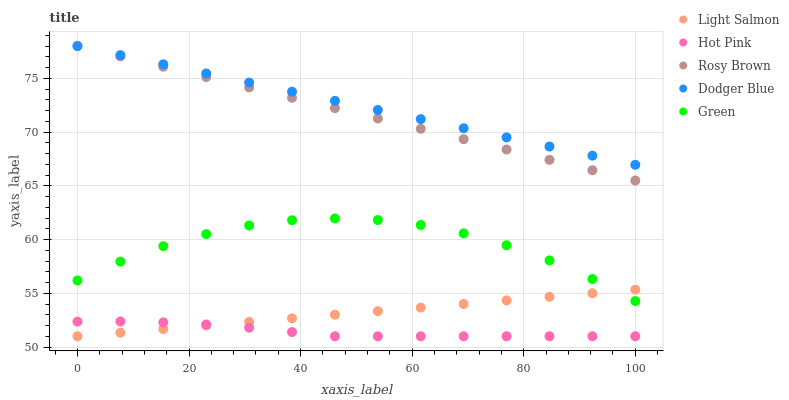Does Hot Pink have the minimum area under the curve?
Answer yes or no. Yes. Does Dodger Blue have the maximum area under the curve?
Answer yes or no. Yes. Does Light Salmon have the minimum area under the curve?
Answer yes or no. No. Does Light Salmon have the maximum area under the curve?
Answer yes or no. No. Is Rosy Brown the smoothest?
Answer yes or no. Yes. Is Green the roughest?
Answer yes or no. Yes. Is Light Salmon the smoothest?
Answer yes or no. No. Is Light Salmon the roughest?
Answer yes or no. No. Does Light Salmon have the lowest value?
Answer yes or no. Yes. Does Dodger Blue have the lowest value?
Answer yes or no. No. Does Rosy Brown have the highest value?
Answer yes or no. Yes. Does Light Salmon have the highest value?
Answer yes or no. No. Is Hot Pink less than Rosy Brown?
Answer yes or no. Yes. Is Dodger Blue greater than Light Salmon?
Answer yes or no. Yes. Does Light Salmon intersect Green?
Answer yes or no. Yes. Is Light Salmon less than Green?
Answer yes or no. No. Is Light Salmon greater than Green?
Answer yes or no. No. Does Hot Pink intersect Rosy Brown?
Answer yes or no. No. 